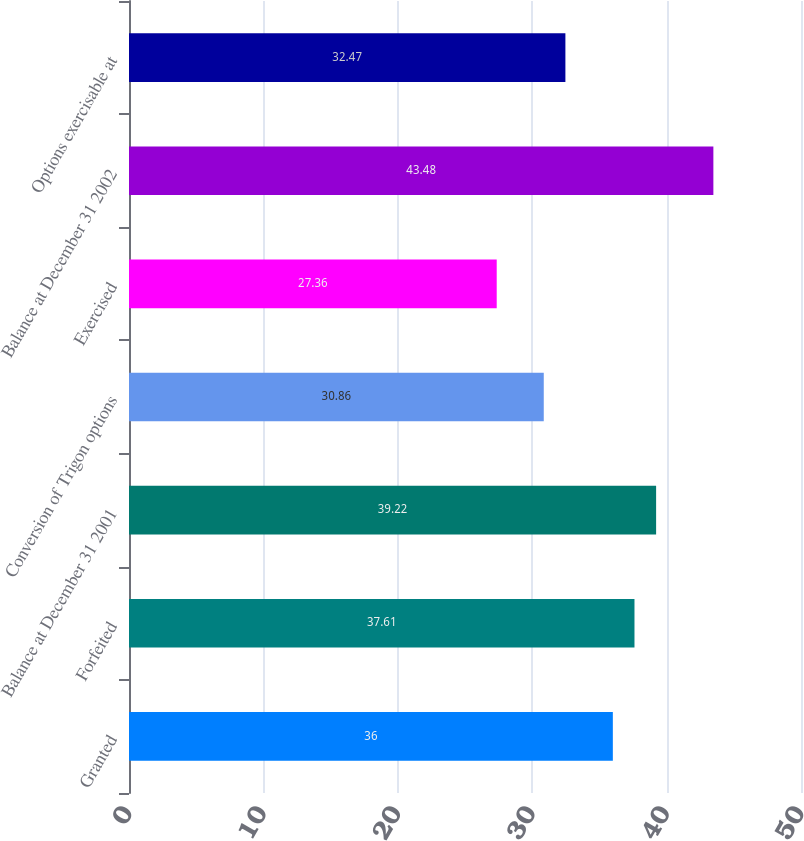<chart> <loc_0><loc_0><loc_500><loc_500><bar_chart><fcel>Granted<fcel>Forfeited<fcel>Balance at December 31 2001<fcel>Conversion of Trigon options<fcel>Exercised<fcel>Balance at December 31 2002<fcel>Options exercisable at<nl><fcel>36<fcel>37.61<fcel>39.22<fcel>30.86<fcel>27.36<fcel>43.48<fcel>32.47<nl></chart> 